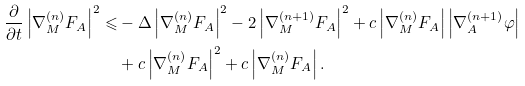<formula> <loc_0><loc_0><loc_500><loc_500>\frac { \partial } { \partial t } \left | { \nabla _ { M } ^ { ( n ) } F _ { A } } \right | ^ { 2 } \leqslant & - \Delta \left | { \nabla _ { M } ^ { ( n ) } F _ { A } } \right | ^ { 2 } - 2 \left | { \nabla _ { M } ^ { ( n + 1 ) } F _ { A } } \right | ^ { 2 } + c \left | { \nabla _ { M } ^ { ( n ) } F _ { A } } \right | \left | { \nabla _ { A } ^ { ( n + 1 ) } \varphi } \right | \\ & + c \left | { \nabla _ { M } ^ { ( n ) } F _ { A } } \right | ^ { 2 } + c \left | { \nabla _ { M } ^ { ( n ) } F _ { A } } \right | .</formula> 